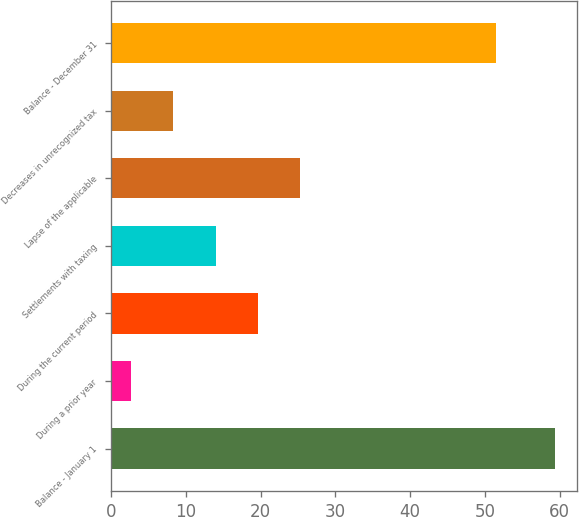<chart> <loc_0><loc_0><loc_500><loc_500><bar_chart><fcel>Balance - January 1<fcel>During a prior year<fcel>During the current period<fcel>Settlements with taxing<fcel>Lapse of the applicable<fcel>Decreases in unrecognized tax<fcel>Balance - December 31<nl><fcel>59.3<fcel>2.7<fcel>19.68<fcel>14.02<fcel>25.34<fcel>8.36<fcel>51.5<nl></chart> 